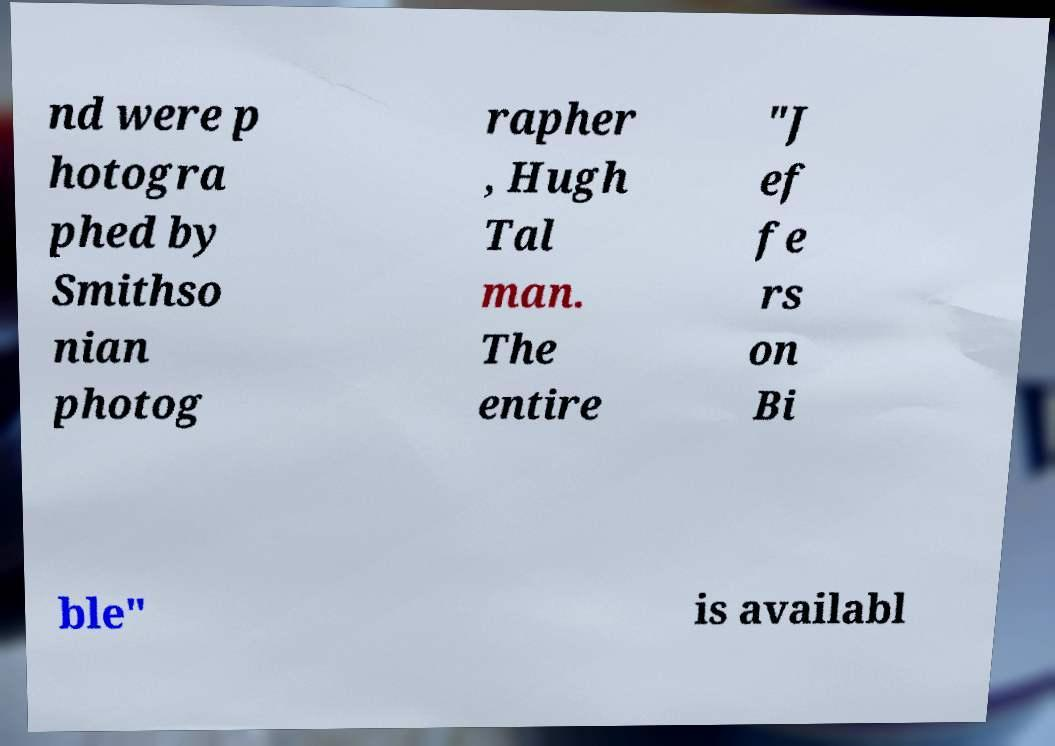I need the written content from this picture converted into text. Can you do that? nd were p hotogra phed by Smithso nian photog rapher , Hugh Tal man. The entire "J ef fe rs on Bi ble" is availabl 